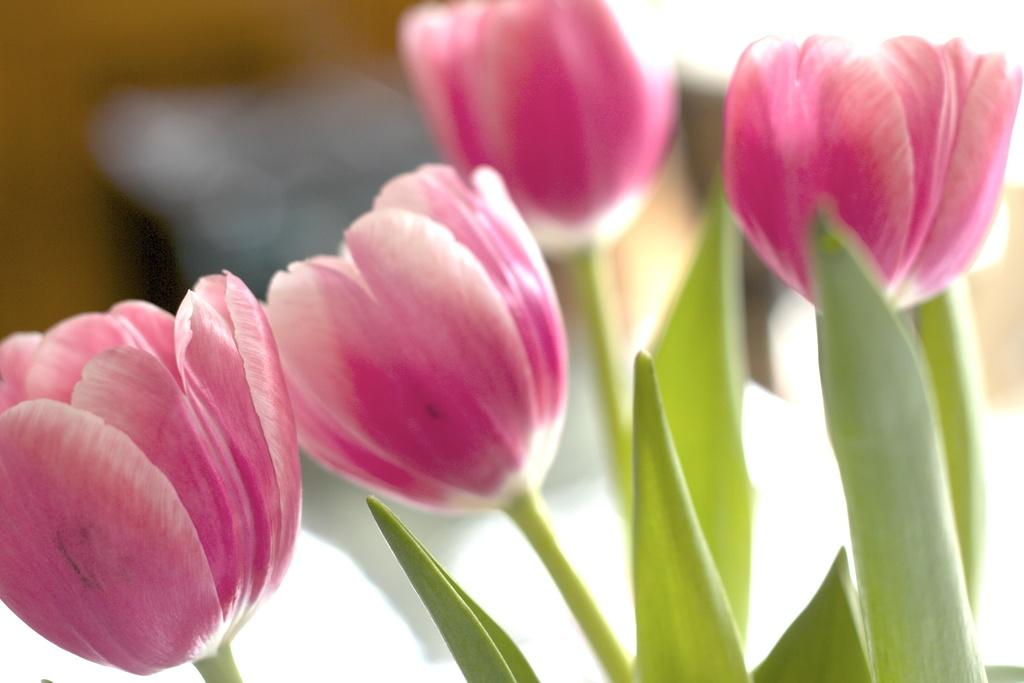What type of flora can be seen in the image? There are flowers in the image. What colors are the flowers? The flowers are pink and white in color. Are there any other parts of the plants visible in the image? Yes, there are leaves associated with the flowers. How would you describe the background of the image? The background of the image is blurred. Can you see a hat on top of the flowers in the image? There is no hat present on top of the flowers in the image. 